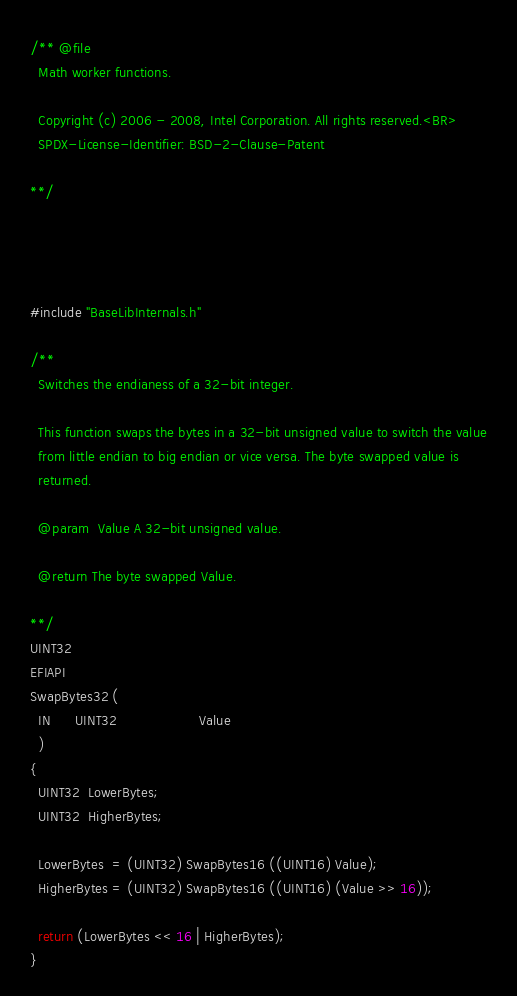<code> <loc_0><loc_0><loc_500><loc_500><_C_>/** @file
  Math worker functions.

  Copyright (c) 2006 - 2008, Intel Corporation. All rights reserved.<BR>
  SPDX-License-Identifier: BSD-2-Clause-Patent

**/




#include "BaseLibInternals.h"

/**
  Switches the endianess of a 32-bit integer.

  This function swaps the bytes in a 32-bit unsigned value to switch the value
  from little endian to big endian or vice versa. The byte swapped value is
  returned.

  @param  Value A 32-bit unsigned value.

  @return The byte swapped Value.

**/
UINT32
EFIAPI
SwapBytes32 (
  IN      UINT32                    Value
  )
{
  UINT32  LowerBytes;
  UINT32  HigherBytes;

  LowerBytes  = (UINT32) SwapBytes16 ((UINT16) Value);
  HigherBytes = (UINT32) SwapBytes16 ((UINT16) (Value >> 16));

  return (LowerBytes << 16 | HigherBytes);
}
</code> 